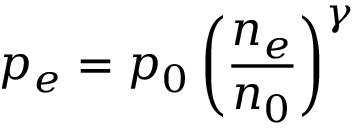<formula> <loc_0><loc_0><loc_500><loc_500>p _ { e } = p _ { 0 } \left ( \frac { n _ { e } } { n _ { 0 } } \right ) ^ { \gamma }</formula> 